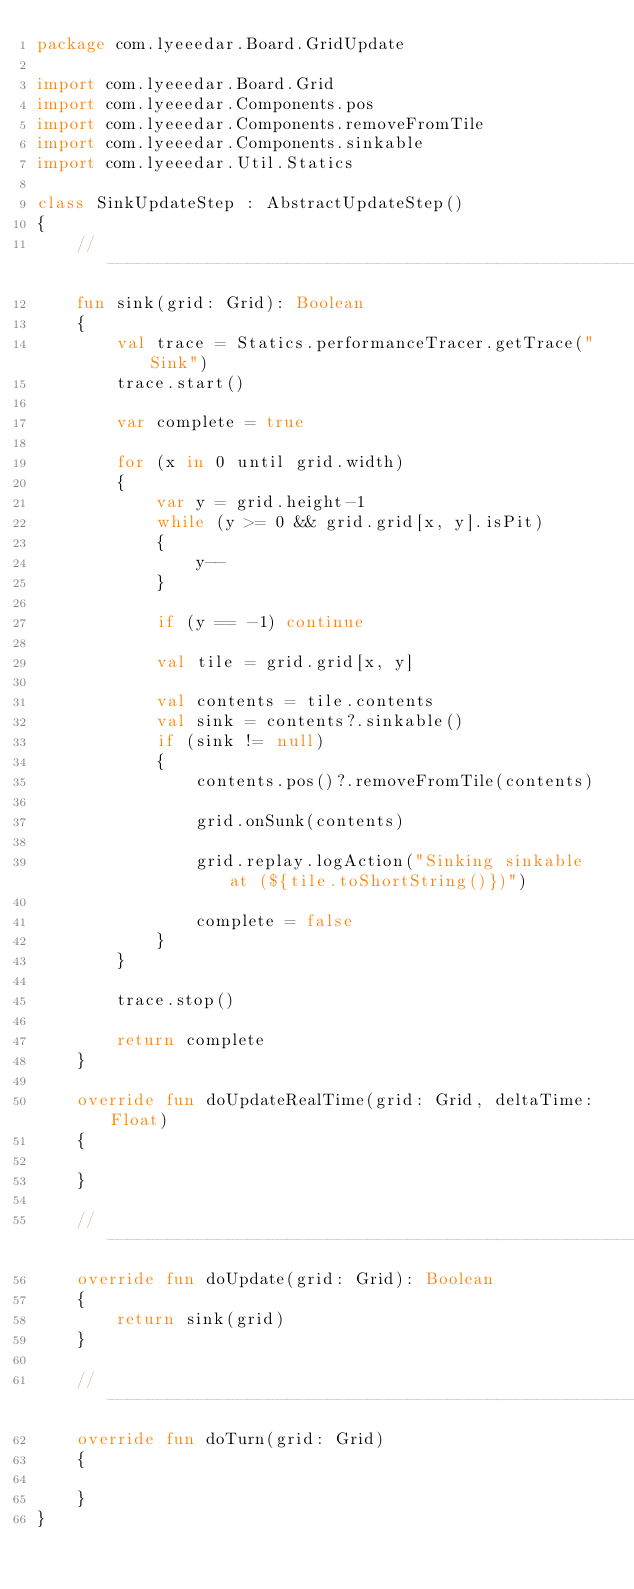Convert code to text. <code><loc_0><loc_0><loc_500><loc_500><_Kotlin_>package com.lyeeedar.Board.GridUpdate

import com.lyeeedar.Board.Grid
import com.lyeeedar.Components.pos
import com.lyeeedar.Components.removeFromTile
import com.lyeeedar.Components.sinkable
import com.lyeeedar.Util.Statics

class SinkUpdateStep : AbstractUpdateStep()
{
	// ----------------------------------------------------------------------
	fun sink(grid: Grid): Boolean
	{
		val trace = Statics.performanceTracer.getTrace("Sink")
		trace.start()

		var complete = true

		for (x in 0 until grid.width)
		{
			var y = grid.height-1
			while (y >= 0 && grid.grid[x, y].isPit)
			{
				y--
			}

			if (y == -1) continue

			val tile = grid.grid[x, y]

			val contents = tile.contents
			val sink = contents?.sinkable()
			if (sink != null)
			{
				contents.pos()?.removeFromTile(contents)

				grid.onSunk(contents)

				grid.replay.logAction("Sinking sinkable at (${tile.toShortString()})")

				complete = false
			}
		}

		trace.stop()

		return complete
	}

	override fun doUpdateRealTime(grid: Grid, deltaTime: Float)
	{

	}

	// ----------------------------------------------------------------------
	override fun doUpdate(grid: Grid): Boolean
	{
		return sink(grid)
	}

	// ----------------------------------------------------------------------
	override fun doTurn(grid: Grid)
	{

	}
}</code> 